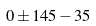Convert formula to latex. <formula><loc_0><loc_0><loc_500><loc_500>0 \pm 1 4 5 - 3 5</formula> 